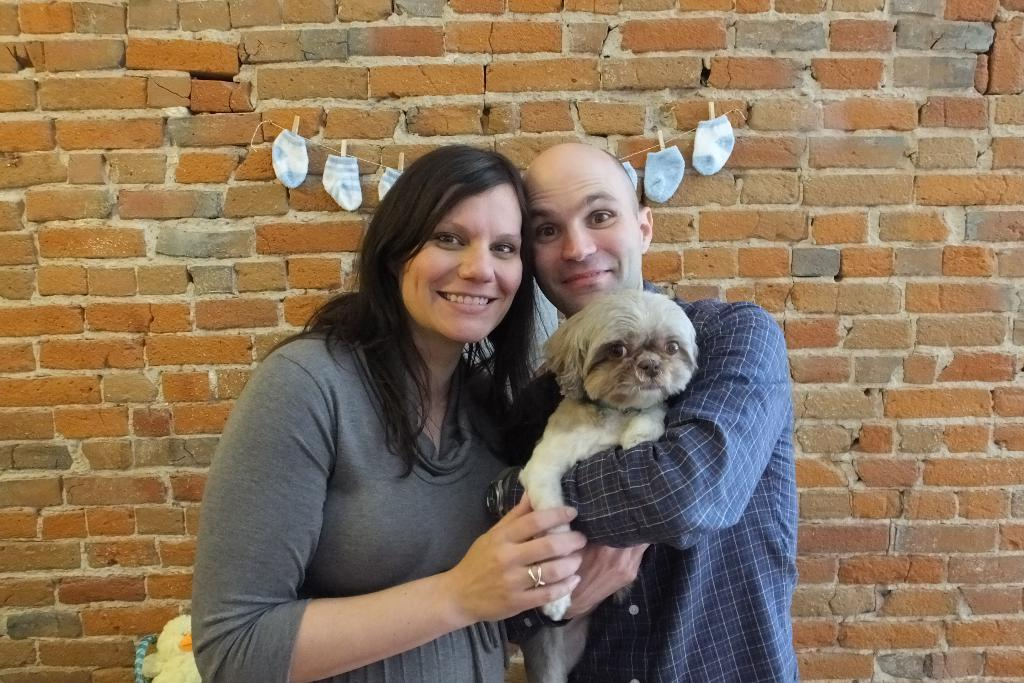Who is present in the image? There is a woman and a man in the image. What are the man and woman doing in the image? The man and woman are holding a dog. What else can be seen to the left side of the woman? There is a toy to the left side of the woman. What is hanging on the wall in the image? There are socks with clips hanging on the wall. What type of corn can be seen growing on the moon in the image? There is no corn or moon present in the image; it features a man, a woman, a dog, a toy, and socks with clips hanging on the wall. 